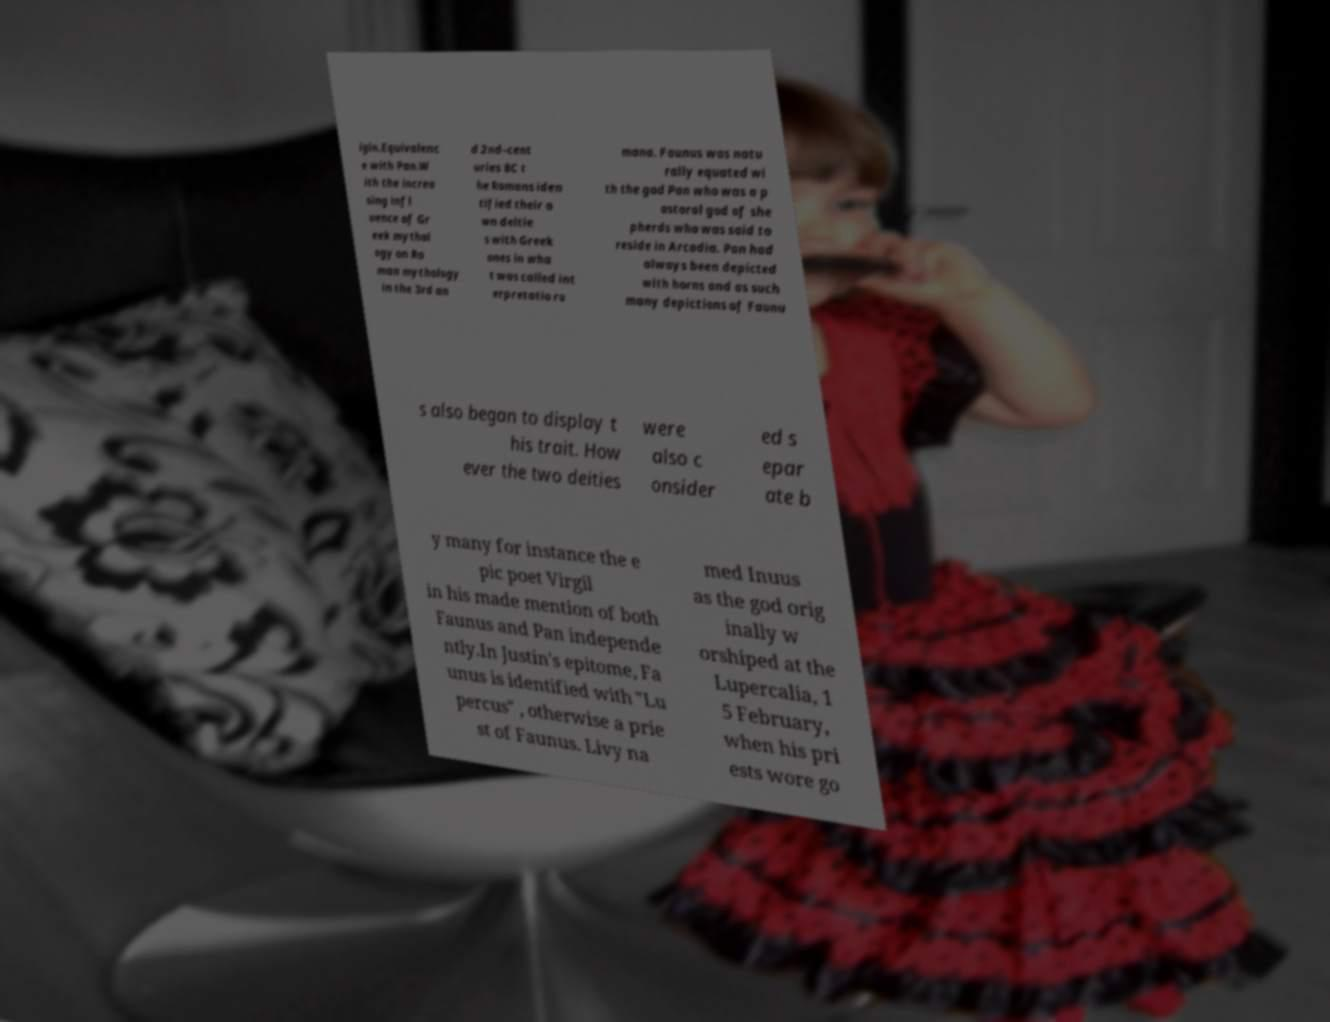There's text embedded in this image that I need extracted. Can you transcribe it verbatim? igin.Equivalenc e with Pan.W ith the increa sing infl uence of Gr eek mythol ogy on Ro man mythology in the 3rd an d 2nd–cent uries BC t he Romans iden tified their o wn deitie s with Greek ones in wha t was called int erpretatio ro mana. Faunus was natu rally equated wi th the god Pan who was a p astoral god of she pherds who was said to reside in Arcadia. Pan had always been depicted with horns and as such many depictions of Faunu s also began to display t his trait. How ever the two deities were also c onsider ed s epar ate b y many for instance the e pic poet Virgil in his made mention of both Faunus and Pan independe ntly.In Justin's epitome, Fa unus is identified with "Lu percus" , otherwise a prie st of Faunus. Livy na med Inuus as the god orig inally w orshiped at the Lupercalia, 1 5 February, when his pri ests wore go 